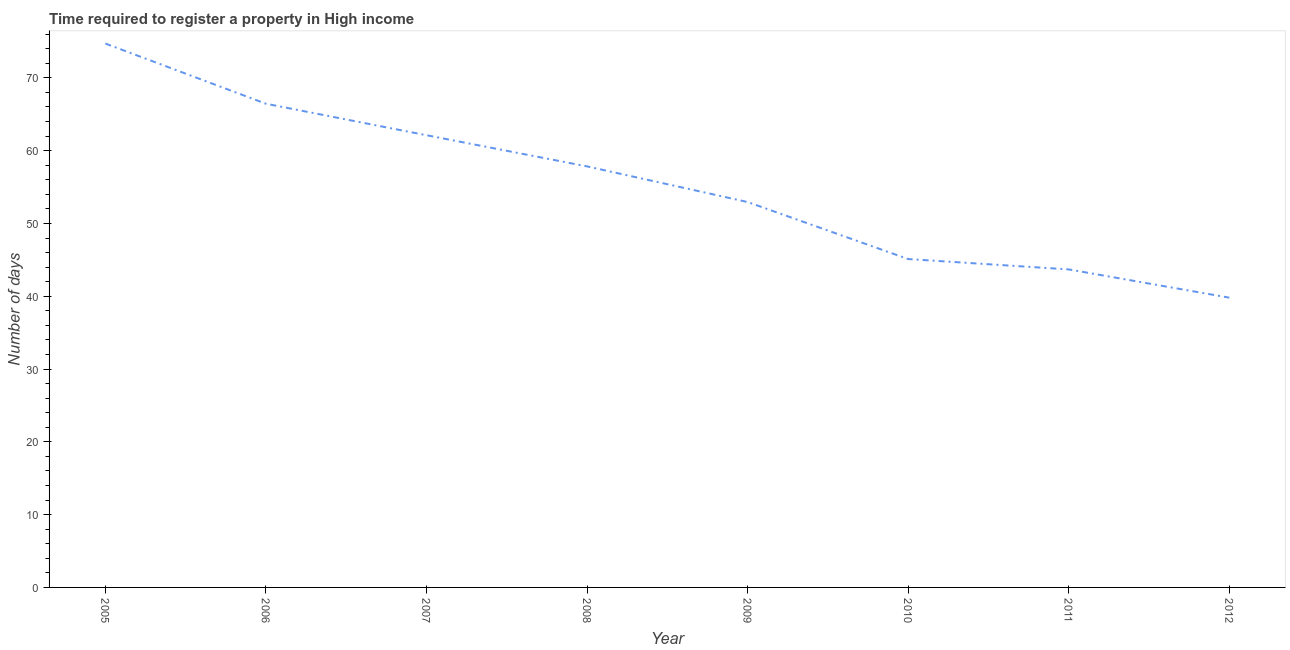What is the number of days required to register property in 2006?
Your response must be concise. 66.45. Across all years, what is the maximum number of days required to register property?
Offer a terse response. 74.72. Across all years, what is the minimum number of days required to register property?
Make the answer very short. 39.81. What is the sum of the number of days required to register property?
Ensure brevity in your answer.  442.68. What is the difference between the number of days required to register property in 2006 and 2007?
Your answer should be very brief. 4.33. What is the average number of days required to register property per year?
Offer a very short reply. 55.34. What is the median number of days required to register property?
Keep it short and to the point. 55.39. What is the ratio of the number of days required to register property in 2007 to that in 2011?
Keep it short and to the point. 1.42. What is the difference between the highest and the second highest number of days required to register property?
Ensure brevity in your answer.  8.27. Is the sum of the number of days required to register property in 2010 and 2011 greater than the maximum number of days required to register property across all years?
Your answer should be compact. Yes. What is the difference between the highest and the lowest number of days required to register property?
Offer a terse response. 34.91. How many lines are there?
Your answer should be very brief. 1. What is the difference between two consecutive major ticks on the Y-axis?
Offer a terse response. 10. Does the graph contain any zero values?
Provide a succinct answer. No. Does the graph contain grids?
Ensure brevity in your answer.  No. What is the title of the graph?
Give a very brief answer. Time required to register a property in High income. What is the label or title of the Y-axis?
Provide a succinct answer. Number of days. What is the Number of days in 2005?
Give a very brief answer. 74.72. What is the Number of days of 2006?
Offer a very short reply. 66.45. What is the Number of days in 2007?
Provide a short and direct response. 62.12. What is the Number of days in 2008?
Give a very brief answer. 57.84. What is the Number of days of 2009?
Give a very brief answer. 52.94. What is the Number of days of 2010?
Give a very brief answer. 45.11. What is the Number of days in 2011?
Offer a terse response. 43.69. What is the Number of days in 2012?
Ensure brevity in your answer.  39.81. What is the difference between the Number of days in 2005 and 2006?
Provide a succinct answer. 8.27. What is the difference between the Number of days in 2005 and 2007?
Give a very brief answer. 12.6. What is the difference between the Number of days in 2005 and 2008?
Your answer should be compact. 16.88. What is the difference between the Number of days in 2005 and 2009?
Your answer should be very brief. 21.77. What is the difference between the Number of days in 2005 and 2010?
Provide a succinct answer. 29.61. What is the difference between the Number of days in 2005 and 2011?
Provide a succinct answer. 31.03. What is the difference between the Number of days in 2005 and 2012?
Offer a very short reply. 34.91. What is the difference between the Number of days in 2006 and 2007?
Provide a succinct answer. 4.33. What is the difference between the Number of days in 2006 and 2008?
Make the answer very short. 8.61. What is the difference between the Number of days in 2006 and 2009?
Your response must be concise. 13.51. What is the difference between the Number of days in 2006 and 2010?
Provide a short and direct response. 21.34. What is the difference between the Number of days in 2006 and 2011?
Offer a very short reply. 22.76. What is the difference between the Number of days in 2006 and 2012?
Offer a terse response. 26.64. What is the difference between the Number of days in 2007 and 2008?
Ensure brevity in your answer.  4.28. What is the difference between the Number of days in 2007 and 2009?
Your response must be concise. 9.18. What is the difference between the Number of days in 2007 and 2010?
Offer a terse response. 17.01. What is the difference between the Number of days in 2007 and 2011?
Make the answer very short. 18.44. What is the difference between the Number of days in 2007 and 2012?
Provide a short and direct response. 22.32. What is the difference between the Number of days in 2008 and 2009?
Offer a terse response. 4.9. What is the difference between the Number of days in 2008 and 2010?
Ensure brevity in your answer.  12.73. What is the difference between the Number of days in 2008 and 2011?
Provide a succinct answer. 14.16. What is the difference between the Number of days in 2008 and 2012?
Make the answer very short. 18.04. What is the difference between the Number of days in 2009 and 2010?
Make the answer very short. 7.83. What is the difference between the Number of days in 2009 and 2011?
Give a very brief answer. 9.26. What is the difference between the Number of days in 2009 and 2012?
Offer a very short reply. 13.14. What is the difference between the Number of days in 2010 and 2011?
Keep it short and to the point. 1.42. What is the difference between the Number of days in 2010 and 2012?
Offer a terse response. 5.3. What is the difference between the Number of days in 2011 and 2012?
Your answer should be very brief. 3.88. What is the ratio of the Number of days in 2005 to that in 2006?
Keep it short and to the point. 1.12. What is the ratio of the Number of days in 2005 to that in 2007?
Make the answer very short. 1.2. What is the ratio of the Number of days in 2005 to that in 2008?
Your answer should be compact. 1.29. What is the ratio of the Number of days in 2005 to that in 2009?
Provide a short and direct response. 1.41. What is the ratio of the Number of days in 2005 to that in 2010?
Ensure brevity in your answer.  1.66. What is the ratio of the Number of days in 2005 to that in 2011?
Your answer should be very brief. 1.71. What is the ratio of the Number of days in 2005 to that in 2012?
Give a very brief answer. 1.88. What is the ratio of the Number of days in 2006 to that in 2007?
Provide a short and direct response. 1.07. What is the ratio of the Number of days in 2006 to that in 2008?
Provide a succinct answer. 1.15. What is the ratio of the Number of days in 2006 to that in 2009?
Your answer should be compact. 1.25. What is the ratio of the Number of days in 2006 to that in 2010?
Make the answer very short. 1.47. What is the ratio of the Number of days in 2006 to that in 2011?
Offer a very short reply. 1.52. What is the ratio of the Number of days in 2006 to that in 2012?
Provide a succinct answer. 1.67. What is the ratio of the Number of days in 2007 to that in 2008?
Provide a succinct answer. 1.07. What is the ratio of the Number of days in 2007 to that in 2009?
Offer a very short reply. 1.17. What is the ratio of the Number of days in 2007 to that in 2010?
Ensure brevity in your answer.  1.38. What is the ratio of the Number of days in 2007 to that in 2011?
Give a very brief answer. 1.42. What is the ratio of the Number of days in 2007 to that in 2012?
Offer a very short reply. 1.56. What is the ratio of the Number of days in 2008 to that in 2009?
Provide a short and direct response. 1.09. What is the ratio of the Number of days in 2008 to that in 2010?
Your response must be concise. 1.28. What is the ratio of the Number of days in 2008 to that in 2011?
Give a very brief answer. 1.32. What is the ratio of the Number of days in 2008 to that in 2012?
Provide a short and direct response. 1.45. What is the ratio of the Number of days in 2009 to that in 2010?
Your response must be concise. 1.17. What is the ratio of the Number of days in 2009 to that in 2011?
Offer a very short reply. 1.21. What is the ratio of the Number of days in 2009 to that in 2012?
Offer a very short reply. 1.33. What is the ratio of the Number of days in 2010 to that in 2011?
Your answer should be compact. 1.03. What is the ratio of the Number of days in 2010 to that in 2012?
Ensure brevity in your answer.  1.13. What is the ratio of the Number of days in 2011 to that in 2012?
Your response must be concise. 1.1. 